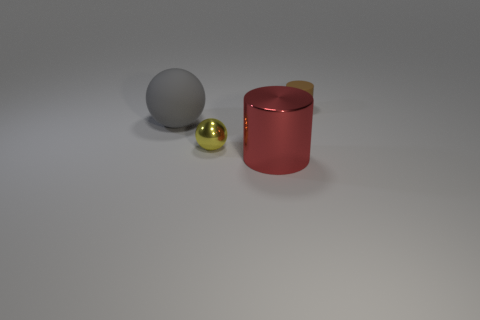Subtract all brown cylinders. How many cylinders are left? 1 Add 2 small yellow spheres. How many objects exist? 6 Subtract all tiny blue shiny things. Subtract all matte objects. How many objects are left? 2 Add 1 big cylinders. How many big cylinders are left? 2 Add 1 gray metal cubes. How many gray metal cubes exist? 1 Subtract 0 purple cubes. How many objects are left? 4 Subtract 1 balls. How many balls are left? 1 Subtract all purple cylinders. Subtract all gray spheres. How many cylinders are left? 2 Subtract all brown cylinders. How many cyan balls are left? 0 